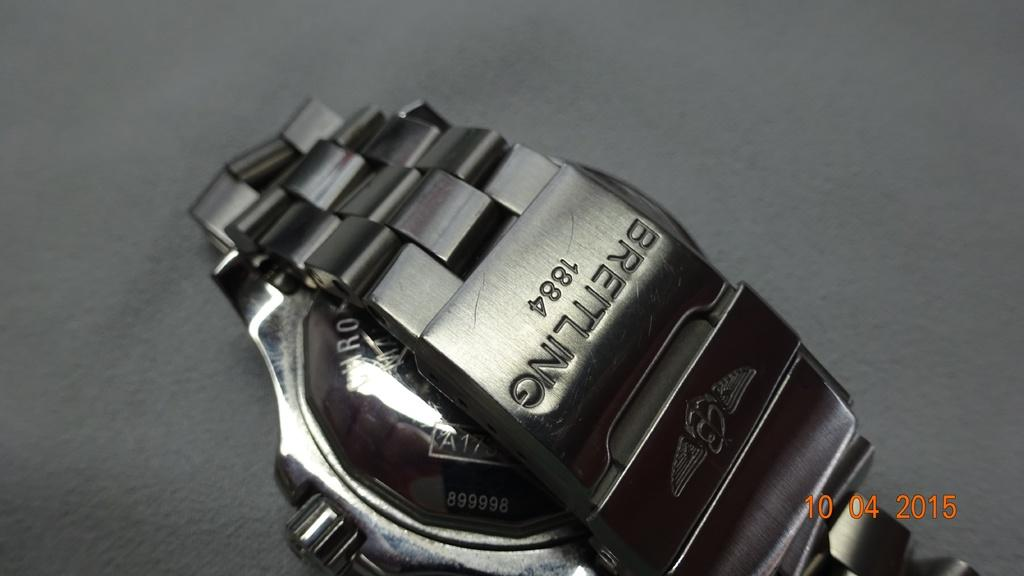<image>
Relay a brief, clear account of the picture shown. A Breitling dark silver wrist watch turned over on his face. 